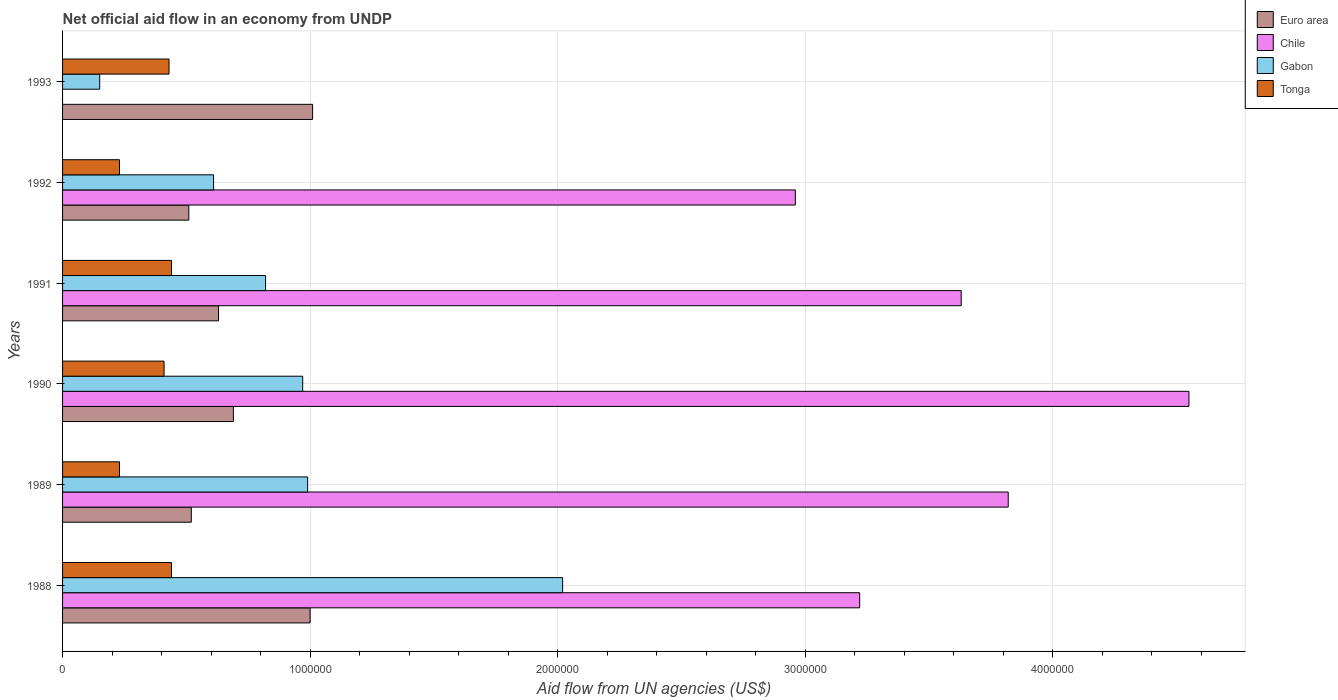How many different coloured bars are there?
Give a very brief answer. 4. How many bars are there on the 4th tick from the bottom?
Offer a very short reply. 4. What is the net official aid flow in Gabon in 1991?
Your answer should be compact. 8.20e+05. Across all years, what is the maximum net official aid flow in Gabon?
Your answer should be very brief. 2.02e+06. What is the total net official aid flow in Gabon in the graph?
Your response must be concise. 5.56e+06. What is the difference between the net official aid flow in Chile in 1990 and the net official aid flow in Gabon in 1988?
Keep it short and to the point. 2.53e+06. What is the average net official aid flow in Chile per year?
Offer a terse response. 3.03e+06. In how many years, is the net official aid flow in Chile greater than 600000 US$?
Your answer should be compact. 5. What is the ratio of the net official aid flow in Tonga in 1990 to that in 1993?
Your answer should be compact. 0.95. Is the net official aid flow in Chile in 1988 less than that in 1990?
Provide a short and direct response. Yes. Is the difference between the net official aid flow in Euro area in 1988 and 1990 greater than the difference between the net official aid flow in Gabon in 1988 and 1990?
Your answer should be compact. No. What is the difference between the highest and the second highest net official aid flow in Chile?
Your answer should be compact. 7.30e+05. What is the difference between the highest and the lowest net official aid flow in Gabon?
Provide a succinct answer. 1.87e+06. Is it the case that in every year, the sum of the net official aid flow in Euro area and net official aid flow in Chile is greater than the sum of net official aid flow in Tonga and net official aid flow in Gabon?
Your answer should be compact. No. How many bars are there?
Offer a very short reply. 23. Does the graph contain any zero values?
Offer a very short reply. Yes. How many legend labels are there?
Ensure brevity in your answer.  4. What is the title of the graph?
Make the answer very short. Net official aid flow in an economy from UNDP. What is the label or title of the X-axis?
Offer a very short reply. Aid flow from UN agencies (US$). What is the label or title of the Y-axis?
Offer a terse response. Years. What is the Aid flow from UN agencies (US$) of Chile in 1988?
Ensure brevity in your answer.  3.22e+06. What is the Aid flow from UN agencies (US$) of Gabon in 1988?
Offer a terse response. 2.02e+06. What is the Aid flow from UN agencies (US$) of Tonga in 1988?
Your response must be concise. 4.40e+05. What is the Aid flow from UN agencies (US$) of Euro area in 1989?
Keep it short and to the point. 5.20e+05. What is the Aid flow from UN agencies (US$) of Chile in 1989?
Make the answer very short. 3.82e+06. What is the Aid flow from UN agencies (US$) in Gabon in 1989?
Give a very brief answer. 9.90e+05. What is the Aid flow from UN agencies (US$) in Euro area in 1990?
Make the answer very short. 6.90e+05. What is the Aid flow from UN agencies (US$) of Chile in 1990?
Keep it short and to the point. 4.55e+06. What is the Aid flow from UN agencies (US$) of Gabon in 1990?
Keep it short and to the point. 9.70e+05. What is the Aid flow from UN agencies (US$) of Tonga in 1990?
Make the answer very short. 4.10e+05. What is the Aid flow from UN agencies (US$) of Euro area in 1991?
Make the answer very short. 6.30e+05. What is the Aid flow from UN agencies (US$) in Chile in 1991?
Provide a succinct answer. 3.63e+06. What is the Aid flow from UN agencies (US$) in Gabon in 1991?
Keep it short and to the point. 8.20e+05. What is the Aid flow from UN agencies (US$) in Euro area in 1992?
Offer a very short reply. 5.10e+05. What is the Aid flow from UN agencies (US$) in Chile in 1992?
Ensure brevity in your answer.  2.96e+06. What is the Aid flow from UN agencies (US$) of Tonga in 1992?
Give a very brief answer. 2.30e+05. What is the Aid flow from UN agencies (US$) of Euro area in 1993?
Provide a short and direct response. 1.01e+06. What is the Aid flow from UN agencies (US$) in Tonga in 1993?
Keep it short and to the point. 4.30e+05. Across all years, what is the maximum Aid flow from UN agencies (US$) of Euro area?
Provide a short and direct response. 1.01e+06. Across all years, what is the maximum Aid flow from UN agencies (US$) of Chile?
Offer a terse response. 4.55e+06. Across all years, what is the maximum Aid flow from UN agencies (US$) in Gabon?
Provide a succinct answer. 2.02e+06. Across all years, what is the minimum Aid flow from UN agencies (US$) in Euro area?
Keep it short and to the point. 5.10e+05. Across all years, what is the minimum Aid flow from UN agencies (US$) in Gabon?
Keep it short and to the point. 1.50e+05. Across all years, what is the minimum Aid flow from UN agencies (US$) of Tonga?
Keep it short and to the point. 2.30e+05. What is the total Aid flow from UN agencies (US$) of Euro area in the graph?
Offer a very short reply. 4.36e+06. What is the total Aid flow from UN agencies (US$) of Chile in the graph?
Offer a terse response. 1.82e+07. What is the total Aid flow from UN agencies (US$) in Gabon in the graph?
Your answer should be compact. 5.56e+06. What is the total Aid flow from UN agencies (US$) of Tonga in the graph?
Your answer should be compact. 2.18e+06. What is the difference between the Aid flow from UN agencies (US$) in Chile in 1988 and that in 1989?
Give a very brief answer. -6.00e+05. What is the difference between the Aid flow from UN agencies (US$) in Gabon in 1988 and that in 1989?
Provide a short and direct response. 1.03e+06. What is the difference between the Aid flow from UN agencies (US$) of Tonga in 1988 and that in 1989?
Provide a succinct answer. 2.10e+05. What is the difference between the Aid flow from UN agencies (US$) of Euro area in 1988 and that in 1990?
Offer a very short reply. 3.10e+05. What is the difference between the Aid flow from UN agencies (US$) of Chile in 1988 and that in 1990?
Offer a very short reply. -1.33e+06. What is the difference between the Aid flow from UN agencies (US$) of Gabon in 1988 and that in 1990?
Your response must be concise. 1.05e+06. What is the difference between the Aid flow from UN agencies (US$) in Euro area in 1988 and that in 1991?
Your answer should be compact. 3.70e+05. What is the difference between the Aid flow from UN agencies (US$) in Chile in 1988 and that in 1991?
Provide a succinct answer. -4.10e+05. What is the difference between the Aid flow from UN agencies (US$) of Gabon in 1988 and that in 1991?
Offer a very short reply. 1.20e+06. What is the difference between the Aid flow from UN agencies (US$) in Euro area in 1988 and that in 1992?
Give a very brief answer. 4.90e+05. What is the difference between the Aid flow from UN agencies (US$) of Chile in 1988 and that in 1992?
Your response must be concise. 2.60e+05. What is the difference between the Aid flow from UN agencies (US$) of Gabon in 1988 and that in 1992?
Your answer should be very brief. 1.41e+06. What is the difference between the Aid flow from UN agencies (US$) of Euro area in 1988 and that in 1993?
Offer a very short reply. -10000. What is the difference between the Aid flow from UN agencies (US$) of Gabon in 1988 and that in 1993?
Keep it short and to the point. 1.87e+06. What is the difference between the Aid flow from UN agencies (US$) in Euro area in 1989 and that in 1990?
Keep it short and to the point. -1.70e+05. What is the difference between the Aid flow from UN agencies (US$) of Chile in 1989 and that in 1990?
Your answer should be compact. -7.30e+05. What is the difference between the Aid flow from UN agencies (US$) in Gabon in 1989 and that in 1990?
Offer a very short reply. 2.00e+04. What is the difference between the Aid flow from UN agencies (US$) in Tonga in 1989 and that in 1991?
Provide a succinct answer. -2.10e+05. What is the difference between the Aid flow from UN agencies (US$) in Euro area in 1989 and that in 1992?
Give a very brief answer. 10000. What is the difference between the Aid flow from UN agencies (US$) in Chile in 1989 and that in 1992?
Keep it short and to the point. 8.60e+05. What is the difference between the Aid flow from UN agencies (US$) of Tonga in 1989 and that in 1992?
Your answer should be compact. 0. What is the difference between the Aid flow from UN agencies (US$) in Euro area in 1989 and that in 1993?
Your answer should be very brief. -4.90e+05. What is the difference between the Aid flow from UN agencies (US$) of Gabon in 1989 and that in 1993?
Your answer should be compact. 8.40e+05. What is the difference between the Aid flow from UN agencies (US$) in Tonga in 1989 and that in 1993?
Ensure brevity in your answer.  -2.00e+05. What is the difference between the Aid flow from UN agencies (US$) in Euro area in 1990 and that in 1991?
Offer a terse response. 6.00e+04. What is the difference between the Aid flow from UN agencies (US$) in Chile in 1990 and that in 1991?
Your response must be concise. 9.20e+05. What is the difference between the Aid flow from UN agencies (US$) of Gabon in 1990 and that in 1991?
Give a very brief answer. 1.50e+05. What is the difference between the Aid flow from UN agencies (US$) in Tonga in 1990 and that in 1991?
Give a very brief answer. -3.00e+04. What is the difference between the Aid flow from UN agencies (US$) of Euro area in 1990 and that in 1992?
Your answer should be compact. 1.80e+05. What is the difference between the Aid flow from UN agencies (US$) in Chile in 1990 and that in 1992?
Offer a very short reply. 1.59e+06. What is the difference between the Aid flow from UN agencies (US$) in Gabon in 1990 and that in 1992?
Provide a succinct answer. 3.60e+05. What is the difference between the Aid flow from UN agencies (US$) of Tonga in 1990 and that in 1992?
Ensure brevity in your answer.  1.80e+05. What is the difference between the Aid flow from UN agencies (US$) in Euro area in 1990 and that in 1993?
Give a very brief answer. -3.20e+05. What is the difference between the Aid flow from UN agencies (US$) of Gabon in 1990 and that in 1993?
Your answer should be very brief. 8.20e+05. What is the difference between the Aid flow from UN agencies (US$) in Chile in 1991 and that in 1992?
Make the answer very short. 6.70e+05. What is the difference between the Aid flow from UN agencies (US$) in Gabon in 1991 and that in 1992?
Provide a short and direct response. 2.10e+05. What is the difference between the Aid flow from UN agencies (US$) of Euro area in 1991 and that in 1993?
Provide a succinct answer. -3.80e+05. What is the difference between the Aid flow from UN agencies (US$) of Gabon in 1991 and that in 1993?
Your answer should be very brief. 6.70e+05. What is the difference between the Aid flow from UN agencies (US$) in Euro area in 1992 and that in 1993?
Your answer should be very brief. -5.00e+05. What is the difference between the Aid flow from UN agencies (US$) in Gabon in 1992 and that in 1993?
Your answer should be compact. 4.60e+05. What is the difference between the Aid flow from UN agencies (US$) in Tonga in 1992 and that in 1993?
Keep it short and to the point. -2.00e+05. What is the difference between the Aid flow from UN agencies (US$) in Euro area in 1988 and the Aid flow from UN agencies (US$) in Chile in 1989?
Ensure brevity in your answer.  -2.82e+06. What is the difference between the Aid flow from UN agencies (US$) in Euro area in 1988 and the Aid flow from UN agencies (US$) in Gabon in 1989?
Your answer should be very brief. 10000. What is the difference between the Aid flow from UN agencies (US$) of Euro area in 1988 and the Aid flow from UN agencies (US$) of Tonga in 1989?
Offer a very short reply. 7.70e+05. What is the difference between the Aid flow from UN agencies (US$) in Chile in 1988 and the Aid flow from UN agencies (US$) in Gabon in 1989?
Ensure brevity in your answer.  2.23e+06. What is the difference between the Aid flow from UN agencies (US$) of Chile in 1988 and the Aid flow from UN agencies (US$) of Tonga in 1989?
Keep it short and to the point. 2.99e+06. What is the difference between the Aid flow from UN agencies (US$) in Gabon in 1988 and the Aid flow from UN agencies (US$) in Tonga in 1989?
Provide a short and direct response. 1.79e+06. What is the difference between the Aid flow from UN agencies (US$) of Euro area in 1988 and the Aid flow from UN agencies (US$) of Chile in 1990?
Keep it short and to the point. -3.55e+06. What is the difference between the Aid flow from UN agencies (US$) in Euro area in 1988 and the Aid flow from UN agencies (US$) in Gabon in 1990?
Your answer should be very brief. 3.00e+04. What is the difference between the Aid flow from UN agencies (US$) in Euro area in 1988 and the Aid flow from UN agencies (US$) in Tonga in 1990?
Provide a succinct answer. 5.90e+05. What is the difference between the Aid flow from UN agencies (US$) of Chile in 1988 and the Aid flow from UN agencies (US$) of Gabon in 1990?
Offer a terse response. 2.25e+06. What is the difference between the Aid flow from UN agencies (US$) of Chile in 1988 and the Aid flow from UN agencies (US$) of Tonga in 1990?
Give a very brief answer. 2.81e+06. What is the difference between the Aid flow from UN agencies (US$) of Gabon in 1988 and the Aid flow from UN agencies (US$) of Tonga in 1990?
Provide a short and direct response. 1.61e+06. What is the difference between the Aid flow from UN agencies (US$) of Euro area in 1988 and the Aid flow from UN agencies (US$) of Chile in 1991?
Your answer should be very brief. -2.63e+06. What is the difference between the Aid flow from UN agencies (US$) in Euro area in 1988 and the Aid flow from UN agencies (US$) in Gabon in 1991?
Offer a terse response. 1.80e+05. What is the difference between the Aid flow from UN agencies (US$) in Euro area in 1988 and the Aid flow from UN agencies (US$) in Tonga in 1991?
Provide a short and direct response. 5.60e+05. What is the difference between the Aid flow from UN agencies (US$) of Chile in 1988 and the Aid flow from UN agencies (US$) of Gabon in 1991?
Ensure brevity in your answer.  2.40e+06. What is the difference between the Aid flow from UN agencies (US$) of Chile in 1988 and the Aid flow from UN agencies (US$) of Tonga in 1991?
Ensure brevity in your answer.  2.78e+06. What is the difference between the Aid flow from UN agencies (US$) of Gabon in 1988 and the Aid flow from UN agencies (US$) of Tonga in 1991?
Make the answer very short. 1.58e+06. What is the difference between the Aid flow from UN agencies (US$) of Euro area in 1988 and the Aid flow from UN agencies (US$) of Chile in 1992?
Your answer should be very brief. -1.96e+06. What is the difference between the Aid flow from UN agencies (US$) of Euro area in 1988 and the Aid flow from UN agencies (US$) of Gabon in 1992?
Ensure brevity in your answer.  3.90e+05. What is the difference between the Aid flow from UN agencies (US$) in Euro area in 1988 and the Aid flow from UN agencies (US$) in Tonga in 1992?
Ensure brevity in your answer.  7.70e+05. What is the difference between the Aid flow from UN agencies (US$) of Chile in 1988 and the Aid flow from UN agencies (US$) of Gabon in 1992?
Your answer should be compact. 2.61e+06. What is the difference between the Aid flow from UN agencies (US$) in Chile in 1988 and the Aid flow from UN agencies (US$) in Tonga in 1992?
Give a very brief answer. 2.99e+06. What is the difference between the Aid flow from UN agencies (US$) of Gabon in 1988 and the Aid flow from UN agencies (US$) of Tonga in 1992?
Provide a succinct answer. 1.79e+06. What is the difference between the Aid flow from UN agencies (US$) in Euro area in 1988 and the Aid flow from UN agencies (US$) in Gabon in 1993?
Your answer should be very brief. 8.50e+05. What is the difference between the Aid flow from UN agencies (US$) of Euro area in 1988 and the Aid flow from UN agencies (US$) of Tonga in 1993?
Your answer should be compact. 5.70e+05. What is the difference between the Aid flow from UN agencies (US$) of Chile in 1988 and the Aid flow from UN agencies (US$) of Gabon in 1993?
Your answer should be compact. 3.07e+06. What is the difference between the Aid flow from UN agencies (US$) in Chile in 1988 and the Aid flow from UN agencies (US$) in Tonga in 1993?
Your answer should be compact. 2.79e+06. What is the difference between the Aid flow from UN agencies (US$) in Gabon in 1988 and the Aid flow from UN agencies (US$) in Tonga in 1993?
Make the answer very short. 1.59e+06. What is the difference between the Aid flow from UN agencies (US$) in Euro area in 1989 and the Aid flow from UN agencies (US$) in Chile in 1990?
Your answer should be very brief. -4.03e+06. What is the difference between the Aid flow from UN agencies (US$) of Euro area in 1989 and the Aid flow from UN agencies (US$) of Gabon in 1990?
Provide a succinct answer. -4.50e+05. What is the difference between the Aid flow from UN agencies (US$) of Euro area in 1989 and the Aid flow from UN agencies (US$) of Tonga in 1990?
Ensure brevity in your answer.  1.10e+05. What is the difference between the Aid flow from UN agencies (US$) in Chile in 1989 and the Aid flow from UN agencies (US$) in Gabon in 1990?
Give a very brief answer. 2.85e+06. What is the difference between the Aid flow from UN agencies (US$) of Chile in 1989 and the Aid flow from UN agencies (US$) of Tonga in 1990?
Your response must be concise. 3.41e+06. What is the difference between the Aid flow from UN agencies (US$) of Gabon in 1989 and the Aid flow from UN agencies (US$) of Tonga in 1990?
Keep it short and to the point. 5.80e+05. What is the difference between the Aid flow from UN agencies (US$) of Euro area in 1989 and the Aid flow from UN agencies (US$) of Chile in 1991?
Give a very brief answer. -3.11e+06. What is the difference between the Aid flow from UN agencies (US$) in Euro area in 1989 and the Aid flow from UN agencies (US$) in Gabon in 1991?
Offer a very short reply. -3.00e+05. What is the difference between the Aid flow from UN agencies (US$) of Chile in 1989 and the Aid flow from UN agencies (US$) of Gabon in 1991?
Your response must be concise. 3.00e+06. What is the difference between the Aid flow from UN agencies (US$) in Chile in 1989 and the Aid flow from UN agencies (US$) in Tonga in 1991?
Give a very brief answer. 3.38e+06. What is the difference between the Aid flow from UN agencies (US$) of Euro area in 1989 and the Aid flow from UN agencies (US$) of Chile in 1992?
Give a very brief answer. -2.44e+06. What is the difference between the Aid flow from UN agencies (US$) of Euro area in 1989 and the Aid flow from UN agencies (US$) of Gabon in 1992?
Provide a succinct answer. -9.00e+04. What is the difference between the Aid flow from UN agencies (US$) in Chile in 1989 and the Aid flow from UN agencies (US$) in Gabon in 1992?
Your answer should be very brief. 3.21e+06. What is the difference between the Aid flow from UN agencies (US$) of Chile in 1989 and the Aid flow from UN agencies (US$) of Tonga in 1992?
Give a very brief answer. 3.59e+06. What is the difference between the Aid flow from UN agencies (US$) of Gabon in 1989 and the Aid flow from UN agencies (US$) of Tonga in 1992?
Your answer should be compact. 7.60e+05. What is the difference between the Aid flow from UN agencies (US$) in Chile in 1989 and the Aid flow from UN agencies (US$) in Gabon in 1993?
Ensure brevity in your answer.  3.67e+06. What is the difference between the Aid flow from UN agencies (US$) in Chile in 1989 and the Aid flow from UN agencies (US$) in Tonga in 1993?
Offer a terse response. 3.39e+06. What is the difference between the Aid flow from UN agencies (US$) in Gabon in 1989 and the Aid flow from UN agencies (US$) in Tonga in 1993?
Provide a short and direct response. 5.60e+05. What is the difference between the Aid flow from UN agencies (US$) of Euro area in 1990 and the Aid flow from UN agencies (US$) of Chile in 1991?
Offer a very short reply. -2.94e+06. What is the difference between the Aid flow from UN agencies (US$) of Euro area in 1990 and the Aid flow from UN agencies (US$) of Tonga in 1991?
Keep it short and to the point. 2.50e+05. What is the difference between the Aid flow from UN agencies (US$) in Chile in 1990 and the Aid flow from UN agencies (US$) in Gabon in 1991?
Provide a succinct answer. 3.73e+06. What is the difference between the Aid flow from UN agencies (US$) of Chile in 1990 and the Aid flow from UN agencies (US$) of Tonga in 1991?
Keep it short and to the point. 4.11e+06. What is the difference between the Aid flow from UN agencies (US$) of Gabon in 1990 and the Aid flow from UN agencies (US$) of Tonga in 1991?
Provide a short and direct response. 5.30e+05. What is the difference between the Aid flow from UN agencies (US$) in Euro area in 1990 and the Aid flow from UN agencies (US$) in Chile in 1992?
Your response must be concise. -2.27e+06. What is the difference between the Aid flow from UN agencies (US$) in Euro area in 1990 and the Aid flow from UN agencies (US$) in Tonga in 1992?
Give a very brief answer. 4.60e+05. What is the difference between the Aid flow from UN agencies (US$) in Chile in 1990 and the Aid flow from UN agencies (US$) in Gabon in 1992?
Provide a short and direct response. 3.94e+06. What is the difference between the Aid flow from UN agencies (US$) in Chile in 1990 and the Aid flow from UN agencies (US$) in Tonga in 1992?
Your response must be concise. 4.32e+06. What is the difference between the Aid flow from UN agencies (US$) of Gabon in 1990 and the Aid flow from UN agencies (US$) of Tonga in 1992?
Your response must be concise. 7.40e+05. What is the difference between the Aid flow from UN agencies (US$) of Euro area in 1990 and the Aid flow from UN agencies (US$) of Gabon in 1993?
Provide a succinct answer. 5.40e+05. What is the difference between the Aid flow from UN agencies (US$) in Euro area in 1990 and the Aid flow from UN agencies (US$) in Tonga in 1993?
Keep it short and to the point. 2.60e+05. What is the difference between the Aid flow from UN agencies (US$) in Chile in 1990 and the Aid flow from UN agencies (US$) in Gabon in 1993?
Give a very brief answer. 4.40e+06. What is the difference between the Aid flow from UN agencies (US$) of Chile in 1990 and the Aid flow from UN agencies (US$) of Tonga in 1993?
Make the answer very short. 4.12e+06. What is the difference between the Aid flow from UN agencies (US$) in Gabon in 1990 and the Aid flow from UN agencies (US$) in Tonga in 1993?
Your answer should be very brief. 5.40e+05. What is the difference between the Aid flow from UN agencies (US$) of Euro area in 1991 and the Aid flow from UN agencies (US$) of Chile in 1992?
Provide a succinct answer. -2.33e+06. What is the difference between the Aid flow from UN agencies (US$) of Chile in 1991 and the Aid flow from UN agencies (US$) of Gabon in 1992?
Give a very brief answer. 3.02e+06. What is the difference between the Aid flow from UN agencies (US$) in Chile in 1991 and the Aid flow from UN agencies (US$) in Tonga in 1992?
Ensure brevity in your answer.  3.40e+06. What is the difference between the Aid flow from UN agencies (US$) in Gabon in 1991 and the Aid flow from UN agencies (US$) in Tonga in 1992?
Give a very brief answer. 5.90e+05. What is the difference between the Aid flow from UN agencies (US$) of Euro area in 1991 and the Aid flow from UN agencies (US$) of Gabon in 1993?
Make the answer very short. 4.80e+05. What is the difference between the Aid flow from UN agencies (US$) in Euro area in 1991 and the Aid flow from UN agencies (US$) in Tonga in 1993?
Ensure brevity in your answer.  2.00e+05. What is the difference between the Aid flow from UN agencies (US$) in Chile in 1991 and the Aid flow from UN agencies (US$) in Gabon in 1993?
Your answer should be compact. 3.48e+06. What is the difference between the Aid flow from UN agencies (US$) of Chile in 1991 and the Aid flow from UN agencies (US$) of Tonga in 1993?
Provide a short and direct response. 3.20e+06. What is the difference between the Aid flow from UN agencies (US$) in Gabon in 1991 and the Aid flow from UN agencies (US$) in Tonga in 1993?
Offer a terse response. 3.90e+05. What is the difference between the Aid flow from UN agencies (US$) in Euro area in 1992 and the Aid flow from UN agencies (US$) in Gabon in 1993?
Provide a succinct answer. 3.60e+05. What is the difference between the Aid flow from UN agencies (US$) of Euro area in 1992 and the Aid flow from UN agencies (US$) of Tonga in 1993?
Your answer should be compact. 8.00e+04. What is the difference between the Aid flow from UN agencies (US$) of Chile in 1992 and the Aid flow from UN agencies (US$) of Gabon in 1993?
Provide a short and direct response. 2.81e+06. What is the difference between the Aid flow from UN agencies (US$) of Chile in 1992 and the Aid flow from UN agencies (US$) of Tonga in 1993?
Offer a terse response. 2.53e+06. What is the average Aid flow from UN agencies (US$) in Euro area per year?
Offer a very short reply. 7.27e+05. What is the average Aid flow from UN agencies (US$) of Chile per year?
Your answer should be very brief. 3.03e+06. What is the average Aid flow from UN agencies (US$) in Gabon per year?
Make the answer very short. 9.27e+05. What is the average Aid flow from UN agencies (US$) in Tonga per year?
Provide a succinct answer. 3.63e+05. In the year 1988, what is the difference between the Aid flow from UN agencies (US$) in Euro area and Aid flow from UN agencies (US$) in Chile?
Keep it short and to the point. -2.22e+06. In the year 1988, what is the difference between the Aid flow from UN agencies (US$) of Euro area and Aid flow from UN agencies (US$) of Gabon?
Ensure brevity in your answer.  -1.02e+06. In the year 1988, what is the difference between the Aid flow from UN agencies (US$) in Euro area and Aid flow from UN agencies (US$) in Tonga?
Your answer should be very brief. 5.60e+05. In the year 1988, what is the difference between the Aid flow from UN agencies (US$) of Chile and Aid flow from UN agencies (US$) of Gabon?
Offer a terse response. 1.20e+06. In the year 1988, what is the difference between the Aid flow from UN agencies (US$) in Chile and Aid flow from UN agencies (US$) in Tonga?
Provide a succinct answer. 2.78e+06. In the year 1988, what is the difference between the Aid flow from UN agencies (US$) in Gabon and Aid flow from UN agencies (US$) in Tonga?
Give a very brief answer. 1.58e+06. In the year 1989, what is the difference between the Aid flow from UN agencies (US$) of Euro area and Aid flow from UN agencies (US$) of Chile?
Provide a succinct answer. -3.30e+06. In the year 1989, what is the difference between the Aid flow from UN agencies (US$) of Euro area and Aid flow from UN agencies (US$) of Gabon?
Provide a succinct answer. -4.70e+05. In the year 1989, what is the difference between the Aid flow from UN agencies (US$) of Euro area and Aid flow from UN agencies (US$) of Tonga?
Offer a very short reply. 2.90e+05. In the year 1989, what is the difference between the Aid flow from UN agencies (US$) of Chile and Aid flow from UN agencies (US$) of Gabon?
Ensure brevity in your answer.  2.83e+06. In the year 1989, what is the difference between the Aid flow from UN agencies (US$) of Chile and Aid flow from UN agencies (US$) of Tonga?
Make the answer very short. 3.59e+06. In the year 1989, what is the difference between the Aid flow from UN agencies (US$) in Gabon and Aid flow from UN agencies (US$) in Tonga?
Offer a very short reply. 7.60e+05. In the year 1990, what is the difference between the Aid flow from UN agencies (US$) of Euro area and Aid flow from UN agencies (US$) of Chile?
Provide a short and direct response. -3.86e+06. In the year 1990, what is the difference between the Aid flow from UN agencies (US$) in Euro area and Aid flow from UN agencies (US$) in Gabon?
Give a very brief answer. -2.80e+05. In the year 1990, what is the difference between the Aid flow from UN agencies (US$) in Euro area and Aid flow from UN agencies (US$) in Tonga?
Keep it short and to the point. 2.80e+05. In the year 1990, what is the difference between the Aid flow from UN agencies (US$) of Chile and Aid flow from UN agencies (US$) of Gabon?
Give a very brief answer. 3.58e+06. In the year 1990, what is the difference between the Aid flow from UN agencies (US$) of Chile and Aid flow from UN agencies (US$) of Tonga?
Keep it short and to the point. 4.14e+06. In the year 1990, what is the difference between the Aid flow from UN agencies (US$) in Gabon and Aid flow from UN agencies (US$) in Tonga?
Ensure brevity in your answer.  5.60e+05. In the year 1991, what is the difference between the Aid flow from UN agencies (US$) in Euro area and Aid flow from UN agencies (US$) in Chile?
Provide a short and direct response. -3.00e+06. In the year 1991, what is the difference between the Aid flow from UN agencies (US$) of Euro area and Aid flow from UN agencies (US$) of Gabon?
Your answer should be compact. -1.90e+05. In the year 1991, what is the difference between the Aid flow from UN agencies (US$) of Euro area and Aid flow from UN agencies (US$) of Tonga?
Offer a very short reply. 1.90e+05. In the year 1991, what is the difference between the Aid flow from UN agencies (US$) in Chile and Aid flow from UN agencies (US$) in Gabon?
Your response must be concise. 2.81e+06. In the year 1991, what is the difference between the Aid flow from UN agencies (US$) in Chile and Aid flow from UN agencies (US$) in Tonga?
Ensure brevity in your answer.  3.19e+06. In the year 1992, what is the difference between the Aid flow from UN agencies (US$) in Euro area and Aid flow from UN agencies (US$) in Chile?
Your answer should be compact. -2.45e+06. In the year 1992, what is the difference between the Aid flow from UN agencies (US$) of Euro area and Aid flow from UN agencies (US$) of Tonga?
Ensure brevity in your answer.  2.80e+05. In the year 1992, what is the difference between the Aid flow from UN agencies (US$) of Chile and Aid flow from UN agencies (US$) of Gabon?
Offer a very short reply. 2.35e+06. In the year 1992, what is the difference between the Aid flow from UN agencies (US$) in Chile and Aid flow from UN agencies (US$) in Tonga?
Provide a succinct answer. 2.73e+06. In the year 1992, what is the difference between the Aid flow from UN agencies (US$) in Gabon and Aid flow from UN agencies (US$) in Tonga?
Your answer should be very brief. 3.80e+05. In the year 1993, what is the difference between the Aid flow from UN agencies (US$) of Euro area and Aid flow from UN agencies (US$) of Gabon?
Give a very brief answer. 8.60e+05. In the year 1993, what is the difference between the Aid flow from UN agencies (US$) of Euro area and Aid flow from UN agencies (US$) of Tonga?
Your answer should be compact. 5.80e+05. In the year 1993, what is the difference between the Aid flow from UN agencies (US$) in Gabon and Aid flow from UN agencies (US$) in Tonga?
Your answer should be very brief. -2.80e+05. What is the ratio of the Aid flow from UN agencies (US$) in Euro area in 1988 to that in 1989?
Your answer should be very brief. 1.92. What is the ratio of the Aid flow from UN agencies (US$) in Chile in 1988 to that in 1989?
Give a very brief answer. 0.84. What is the ratio of the Aid flow from UN agencies (US$) in Gabon in 1988 to that in 1989?
Ensure brevity in your answer.  2.04. What is the ratio of the Aid flow from UN agencies (US$) in Tonga in 1988 to that in 1989?
Keep it short and to the point. 1.91. What is the ratio of the Aid flow from UN agencies (US$) of Euro area in 1988 to that in 1990?
Provide a short and direct response. 1.45. What is the ratio of the Aid flow from UN agencies (US$) in Chile in 1988 to that in 1990?
Keep it short and to the point. 0.71. What is the ratio of the Aid flow from UN agencies (US$) of Gabon in 1988 to that in 1990?
Provide a succinct answer. 2.08. What is the ratio of the Aid flow from UN agencies (US$) in Tonga in 1988 to that in 1990?
Your answer should be compact. 1.07. What is the ratio of the Aid flow from UN agencies (US$) of Euro area in 1988 to that in 1991?
Provide a short and direct response. 1.59. What is the ratio of the Aid flow from UN agencies (US$) of Chile in 1988 to that in 1991?
Offer a very short reply. 0.89. What is the ratio of the Aid flow from UN agencies (US$) of Gabon in 1988 to that in 1991?
Your answer should be compact. 2.46. What is the ratio of the Aid flow from UN agencies (US$) of Tonga in 1988 to that in 1991?
Give a very brief answer. 1. What is the ratio of the Aid flow from UN agencies (US$) in Euro area in 1988 to that in 1992?
Your answer should be very brief. 1.96. What is the ratio of the Aid flow from UN agencies (US$) in Chile in 1988 to that in 1992?
Keep it short and to the point. 1.09. What is the ratio of the Aid flow from UN agencies (US$) in Gabon in 1988 to that in 1992?
Offer a very short reply. 3.31. What is the ratio of the Aid flow from UN agencies (US$) in Tonga in 1988 to that in 1992?
Your answer should be very brief. 1.91. What is the ratio of the Aid flow from UN agencies (US$) of Gabon in 1988 to that in 1993?
Make the answer very short. 13.47. What is the ratio of the Aid flow from UN agencies (US$) in Tonga in 1988 to that in 1993?
Keep it short and to the point. 1.02. What is the ratio of the Aid flow from UN agencies (US$) in Euro area in 1989 to that in 1990?
Offer a terse response. 0.75. What is the ratio of the Aid flow from UN agencies (US$) in Chile in 1989 to that in 1990?
Your response must be concise. 0.84. What is the ratio of the Aid flow from UN agencies (US$) in Gabon in 1989 to that in 1990?
Your answer should be compact. 1.02. What is the ratio of the Aid flow from UN agencies (US$) of Tonga in 1989 to that in 1990?
Ensure brevity in your answer.  0.56. What is the ratio of the Aid flow from UN agencies (US$) of Euro area in 1989 to that in 1991?
Give a very brief answer. 0.83. What is the ratio of the Aid flow from UN agencies (US$) in Chile in 1989 to that in 1991?
Your response must be concise. 1.05. What is the ratio of the Aid flow from UN agencies (US$) of Gabon in 1989 to that in 1991?
Your response must be concise. 1.21. What is the ratio of the Aid flow from UN agencies (US$) of Tonga in 1989 to that in 1991?
Offer a very short reply. 0.52. What is the ratio of the Aid flow from UN agencies (US$) in Euro area in 1989 to that in 1992?
Make the answer very short. 1.02. What is the ratio of the Aid flow from UN agencies (US$) of Chile in 1989 to that in 1992?
Offer a very short reply. 1.29. What is the ratio of the Aid flow from UN agencies (US$) of Gabon in 1989 to that in 1992?
Give a very brief answer. 1.62. What is the ratio of the Aid flow from UN agencies (US$) in Euro area in 1989 to that in 1993?
Provide a short and direct response. 0.51. What is the ratio of the Aid flow from UN agencies (US$) in Gabon in 1989 to that in 1993?
Your answer should be compact. 6.6. What is the ratio of the Aid flow from UN agencies (US$) of Tonga in 1989 to that in 1993?
Offer a terse response. 0.53. What is the ratio of the Aid flow from UN agencies (US$) in Euro area in 1990 to that in 1991?
Your answer should be very brief. 1.1. What is the ratio of the Aid flow from UN agencies (US$) of Chile in 1990 to that in 1991?
Provide a succinct answer. 1.25. What is the ratio of the Aid flow from UN agencies (US$) in Gabon in 1990 to that in 1991?
Provide a succinct answer. 1.18. What is the ratio of the Aid flow from UN agencies (US$) in Tonga in 1990 to that in 1991?
Provide a short and direct response. 0.93. What is the ratio of the Aid flow from UN agencies (US$) of Euro area in 1990 to that in 1992?
Provide a short and direct response. 1.35. What is the ratio of the Aid flow from UN agencies (US$) of Chile in 1990 to that in 1992?
Make the answer very short. 1.54. What is the ratio of the Aid flow from UN agencies (US$) in Gabon in 1990 to that in 1992?
Provide a short and direct response. 1.59. What is the ratio of the Aid flow from UN agencies (US$) in Tonga in 1990 to that in 1992?
Provide a short and direct response. 1.78. What is the ratio of the Aid flow from UN agencies (US$) in Euro area in 1990 to that in 1993?
Keep it short and to the point. 0.68. What is the ratio of the Aid flow from UN agencies (US$) in Gabon in 1990 to that in 1993?
Offer a terse response. 6.47. What is the ratio of the Aid flow from UN agencies (US$) in Tonga in 1990 to that in 1993?
Ensure brevity in your answer.  0.95. What is the ratio of the Aid flow from UN agencies (US$) in Euro area in 1991 to that in 1992?
Offer a very short reply. 1.24. What is the ratio of the Aid flow from UN agencies (US$) in Chile in 1991 to that in 1992?
Your answer should be very brief. 1.23. What is the ratio of the Aid flow from UN agencies (US$) in Gabon in 1991 to that in 1992?
Offer a very short reply. 1.34. What is the ratio of the Aid flow from UN agencies (US$) in Tonga in 1991 to that in 1992?
Make the answer very short. 1.91. What is the ratio of the Aid flow from UN agencies (US$) of Euro area in 1991 to that in 1993?
Provide a short and direct response. 0.62. What is the ratio of the Aid flow from UN agencies (US$) in Gabon in 1991 to that in 1993?
Offer a terse response. 5.47. What is the ratio of the Aid flow from UN agencies (US$) in Tonga in 1991 to that in 1993?
Give a very brief answer. 1.02. What is the ratio of the Aid flow from UN agencies (US$) in Euro area in 1992 to that in 1993?
Your answer should be compact. 0.51. What is the ratio of the Aid flow from UN agencies (US$) in Gabon in 1992 to that in 1993?
Provide a succinct answer. 4.07. What is the ratio of the Aid flow from UN agencies (US$) in Tonga in 1992 to that in 1993?
Ensure brevity in your answer.  0.53. What is the difference between the highest and the second highest Aid flow from UN agencies (US$) in Chile?
Keep it short and to the point. 7.30e+05. What is the difference between the highest and the second highest Aid flow from UN agencies (US$) of Gabon?
Provide a short and direct response. 1.03e+06. What is the difference between the highest and the second highest Aid flow from UN agencies (US$) of Tonga?
Provide a short and direct response. 0. What is the difference between the highest and the lowest Aid flow from UN agencies (US$) in Chile?
Provide a succinct answer. 4.55e+06. What is the difference between the highest and the lowest Aid flow from UN agencies (US$) of Gabon?
Ensure brevity in your answer.  1.87e+06. 